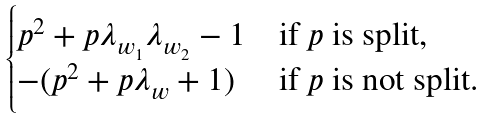<formula> <loc_0><loc_0><loc_500><loc_500>\begin{cases} p ^ { 2 } + p \lambda _ { w _ { 1 } } \lambda _ { w _ { 2 } } - 1 & \text {if $p$ is split,} \\ - ( p ^ { 2 } + p \lambda _ { w } + 1 ) & \text {if $p$ is not split} . \end{cases}</formula> 